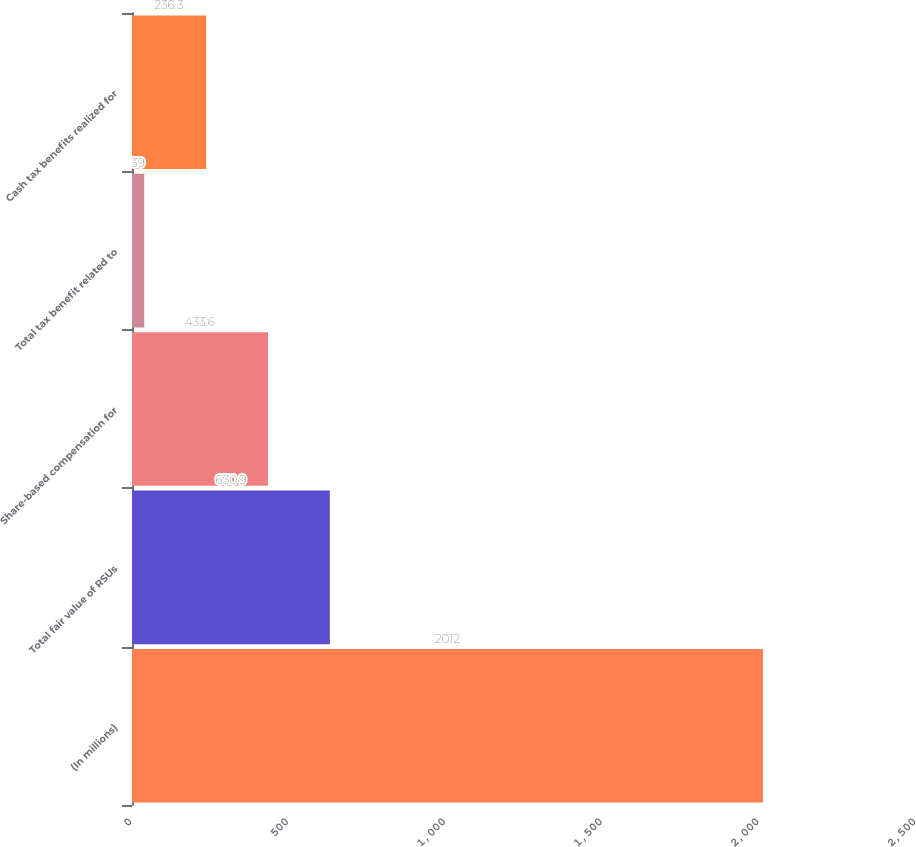<chart> <loc_0><loc_0><loc_500><loc_500><bar_chart><fcel>(In millions)<fcel>Total fair value of RSUs<fcel>Share-based compensation for<fcel>Total tax benefit related to<fcel>Cash tax benefits realized for<nl><fcel>2012<fcel>630.9<fcel>433.6<fcel>39<fcel>236.3<nl></chart> 